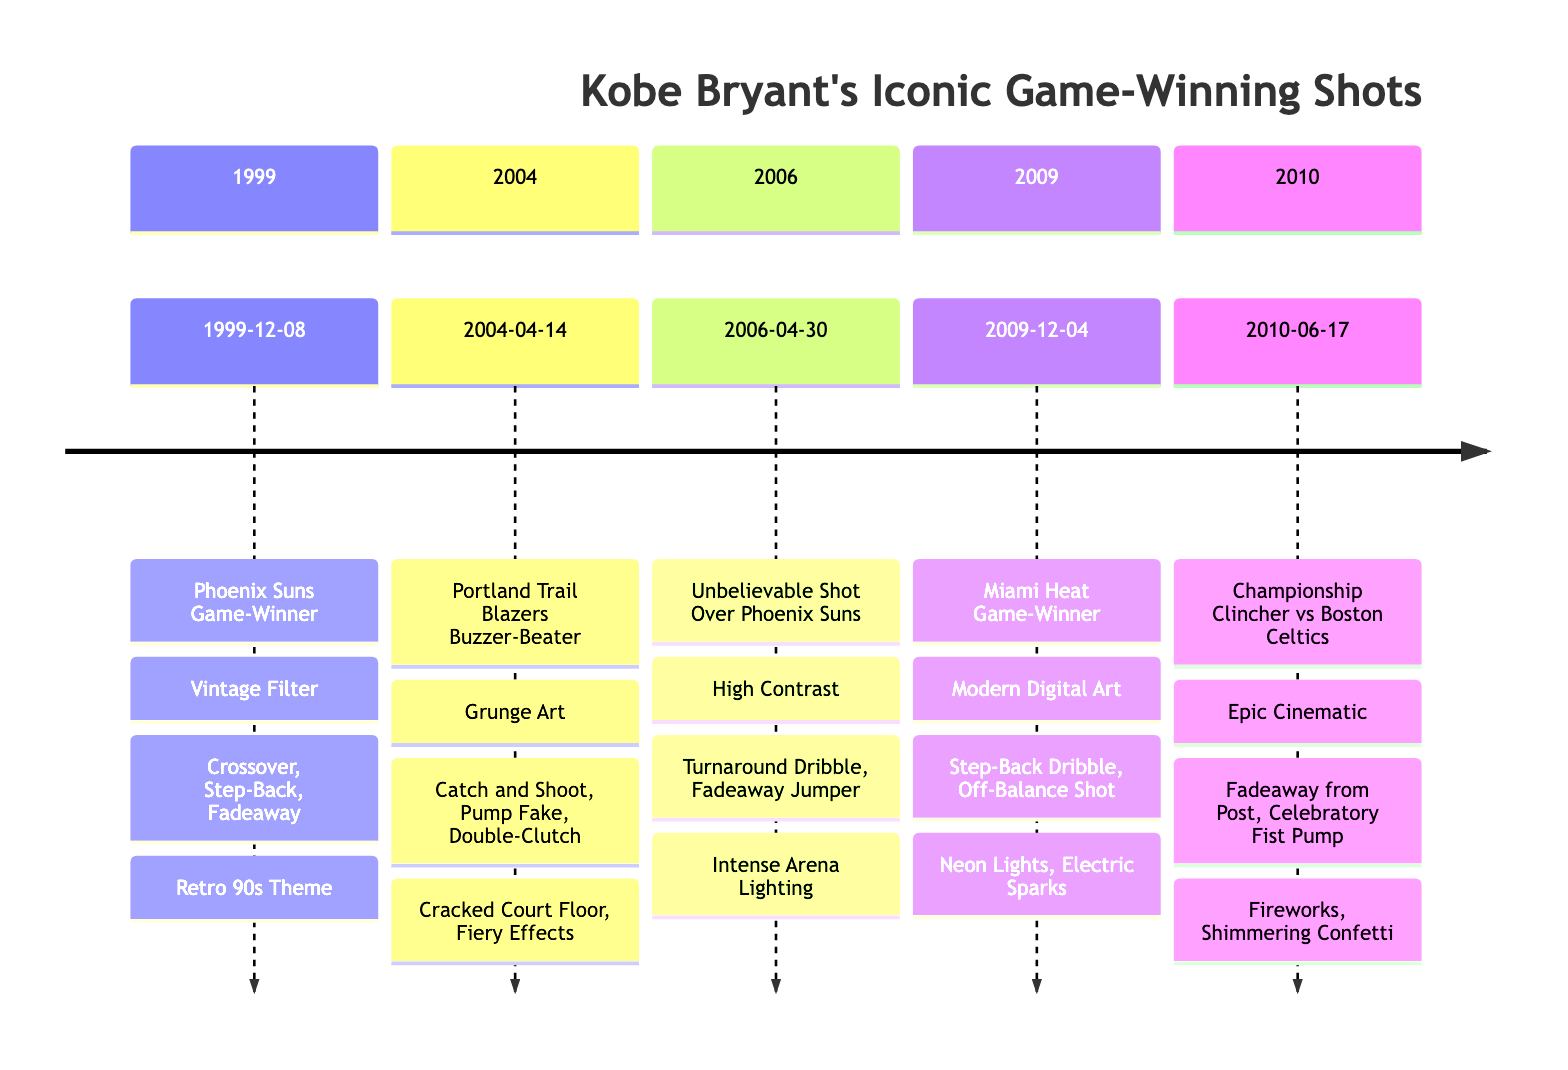What is the title of the first game-winning shot on the timeline? The first game-winning shot listed on the timeline is "Kobe's Game-Winner Against the Phoenix Suns," which appears in the section for 1999.
Answer: Kobe's Game-Winner Against the Phoenix Suns How many shots are depicted on the timeline? By counting the sections of the timeline, each representing a different game-winning shot by Kobe, we find there are a total of five shots in the timeline.
Answer: 5 Which illustration style is used for the game-winner against the Miami Heat? The game-winner against the Miami Heat in 2009 is illustrated with the style "Modern Digital Art," which is specified in its corresponding section.
Answer: Modern Digital Art What was the date of the buzzer-beater against the Portland Trail Blazers? Referring to the timeline, the specific date mentioned for the buzzer-beater against the Portland Trail Blazers is April 14, 2004, as highlighted in that section.
Answer: 2004-04-14 What motion sequence involves a step-back dribble? The timelines for both the Miami Heat game-winner in 2009 and the game against the Phoenix Suns in 1999 contain "Step-Back" in their motion sequences; hence, either could be a valid answer. However, since the question targets one particular time, we refer to the one that includes it in detail.
Answer: Step-Back Dribble Which background effect accompanies the Championship Clincher against the Boston Celtics? The background effects listed for the championship clincher include "Fireworks" and "Shimmering Confetti," both serving to enhance the illustration of this moment.
Answer: Fireworks, Shimmering Confetti In which year did Kobe make the unbelievable shot over the Phoenix Suns? The year specified for this particular shot, which further solidified Kobe's reputation, is 2006, as indicated in that section of the timeline.
Answer: 2006 What is the second motion sequence listed for Kobe's game-winner against the Phoenix Suns in 1999? The motion sequences for the game-winner against the Phoenix Suns are listed as "Crossover Dribble," "Step-Back," and "Fadeaway Jumper," with "Step-Back" being the second in this sequence.
Answer: Step-Back 